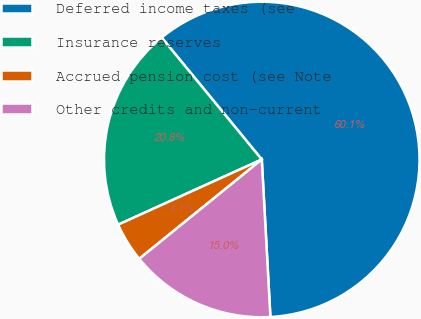<chart> <loc_0><loc_0><loc_500><loc_500><pie_chart><fcel>Deferred income taxes (see<fcel>Insurance reserves<fcel>Accrued pension cost (see Note<fcel>Other credits and non-current<nl><fcel>60.07%<fcel>20.84%<fcel>4.06%<fcel>15.03%<nl></chart> 